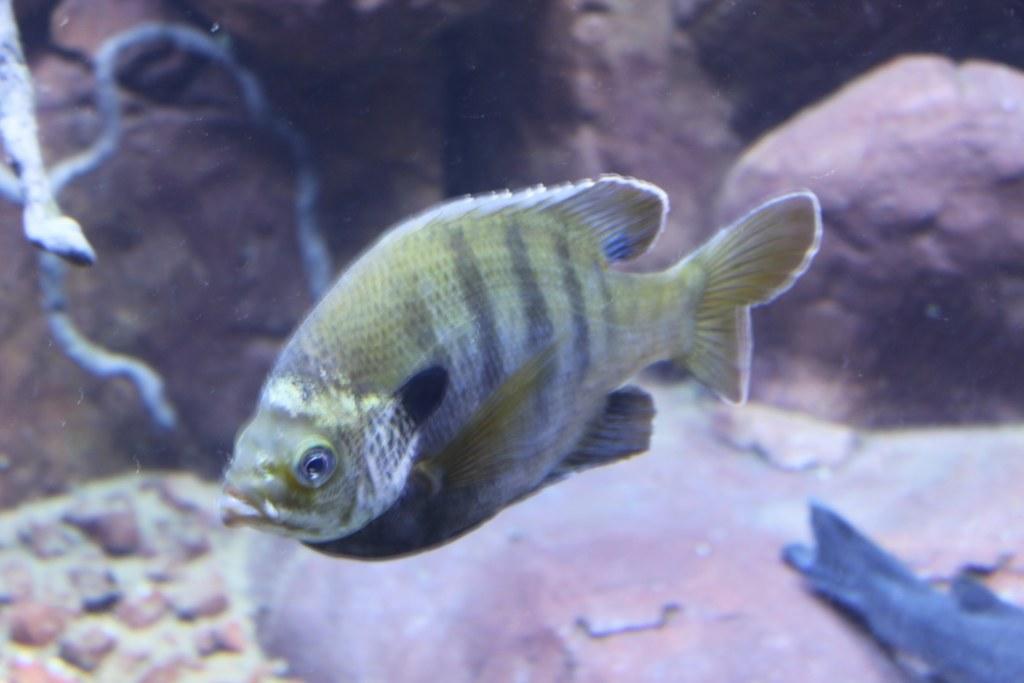Describe this image in one or two sentences. In this image I can see two fish in the water. On the left side of the image I can see a grey colour thing and I can also see this image is little bit blurry. 